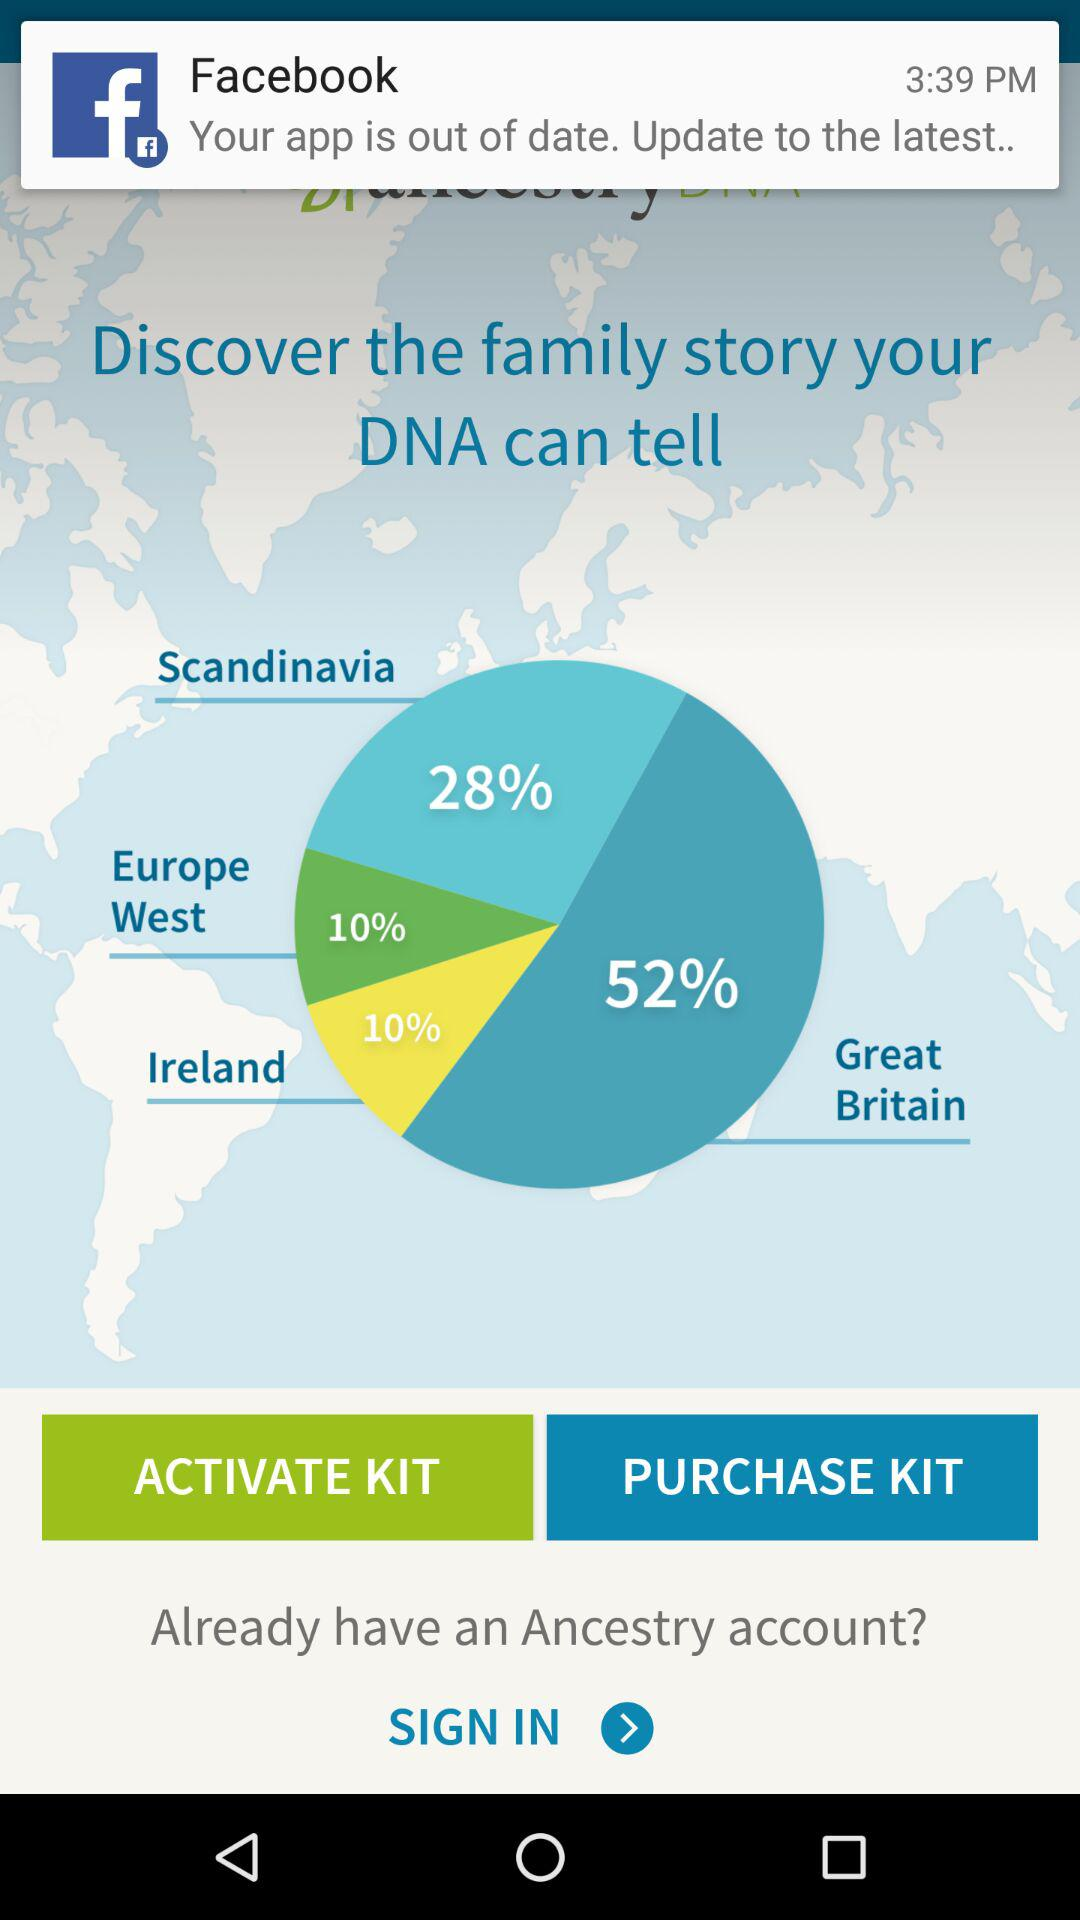What is the percentage of Ireland? The percentage is 10. 